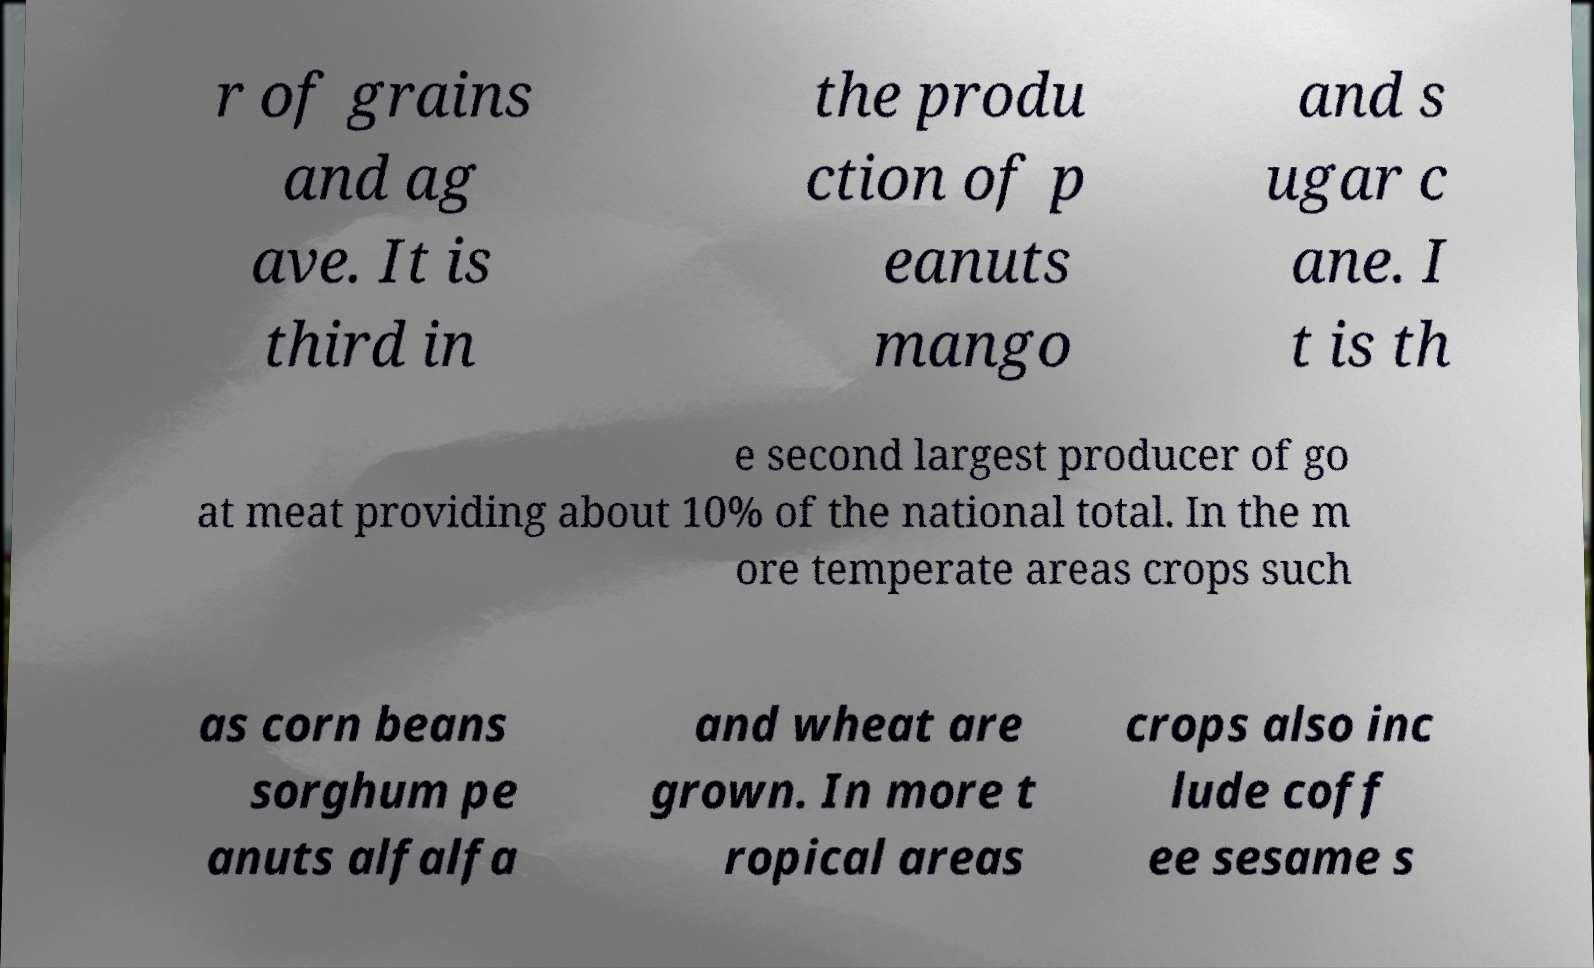Could you extract and type out the text from this image? r of grains and ag ave. It is third in the produ ction of p eanuts mango and s ugar c ane. I t is th e second largest producer of go at meat providing about 10% of the national total. In the m ore temperate areas crops such as corn beans sorghum pe anuts alfalfa and wheat are grown. In more t ropical areas crops also inc lude coff ee sesame s 